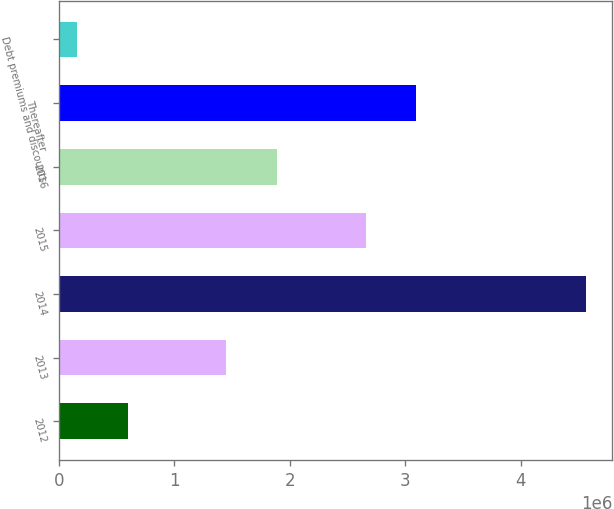Convert chart. <chart><loc_0><loc_0><loc_500><loc_500><bar_chart><fcel>2012<fcel>2013<fcel>2014<fcel>2015<fcel>2016<fcel>Thereafter<fcel>Debt premiums and discounts<nl><fcel>594645<fcel>1.44507e+06<fcel>4.56549e+06<fcel>2.65639e+06<fcel>1.88628e+06<fcel>3.09759e+06<fcel>153440<nl></chart> 